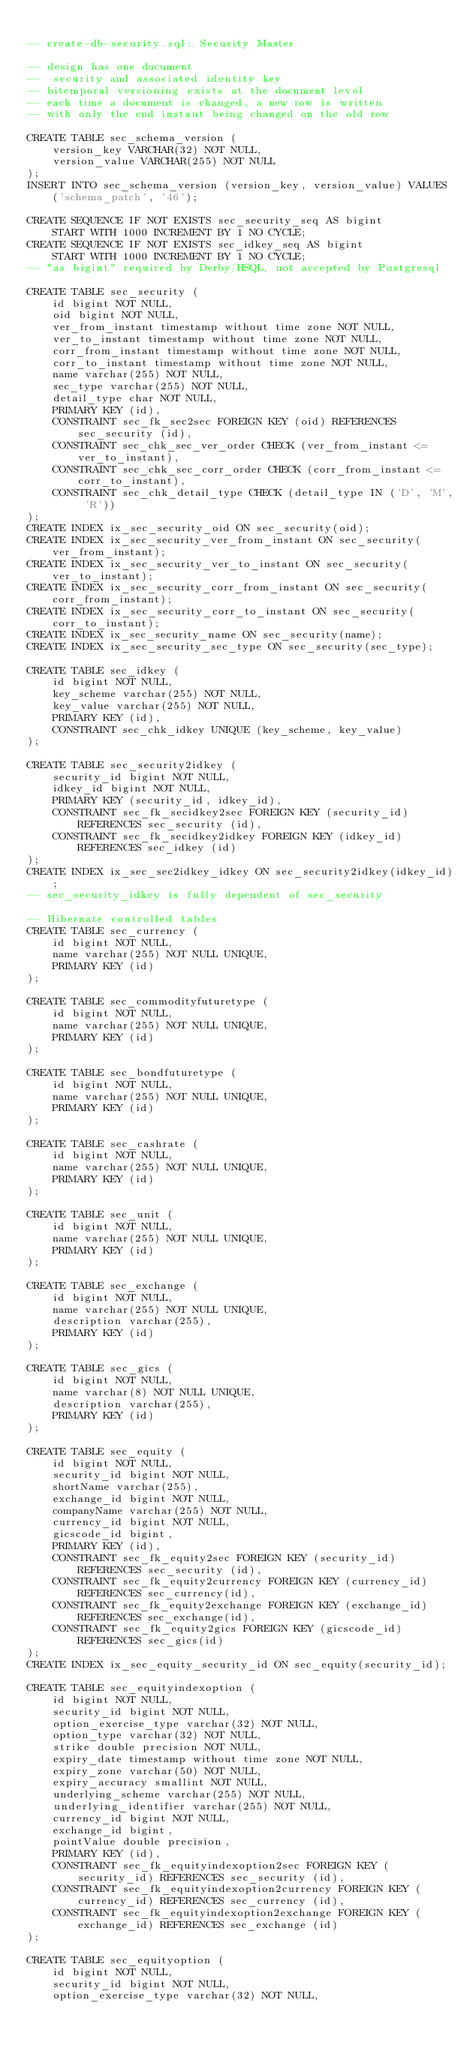<code> <loc_0><loc_0><loc_500><loc_500><_SQL_>
-- create-db-security.sql: Security Master

-- design has one document
--  security and associated identity key
-- bitemporal versioning exists at the document level
-- each time a document is changed, a new row is written
-- with only the end instant being changed on the old row

CREATE TABLE sec_schema_version (
    version_key VARCHAR(32) NOT NULL,
    version_value VARCHAR(255) NOT NULL
);
INSERT INTO sec_schema_version (version_key, version_value) VALUES ('schema_patch', '46');

CREATE SEQUENCE IF NOT EXISTS sec_security_seq AS bigint
    START WITH 1000 INCREMENT BY 1 NO CYCLE;
CREATE SEQUENCE IF NOT EXISTS sec_idkey_seq AS bigint
    START WITH 1000 INCREMENT BY 1 NO CYCLE;
-- "as bigint" required by Derby/HSQL, not accepted by Postgresql

CREATE TABLE sec_security (
    id bigint NOT NULL,
    oid bigint NOT NULL,
    ver_from_instant timestamp without time zone NOT NULL,
    ver_to_instant timestamp without time zone NOT NULL,
    corr_from_instant timestamp without time zone NOT NULL,
    corr_to_instant timestamp without time zone NOT NULL,
    name varchar(255) NOT NULL,
    sec_type varchar(255) NOT NULL,
    detail_type char NOT NULL,
    PRIMARY KEY (id),
    CONSTRAINT sec_fk_sec2sec FOREIGN KEY (oid) REFERENCES sec_security (id),
    CONSTRAINT sec_chk_sec_ver_order CHECK (ver_from_instant <= ver_to_instant),
    CONSTRAINT sec_chk_sec_corr_order CHECK (corr_from_instant <= corr_to_instant),
    CONSTRAINT sec_chk_detail_type CHECK (detail_type IN ('D', 'M', 'R'))
);
CREATE INDEX ix_sec_security_oid ON sec_security(oid);
CREATE INDEX ix_sec_security_ver_from_instant ON sec_security(ver_from_instant);
CREATE INDEX ix_sec_security_ver_to_instant ON sec_security(ver_to_instant);
CREATE INDEX ix_sec_security_corr_from_instant ON sec_security(corr_from_instant);
CREATE INDEX ix_sec_security_corr_to_instant ON sec_security(corr_to_instant);
CREATE INDEX ix_sec_security_name ON sec_security(name);
CREATE INDEX ix_sec_security_sec_type ON sec_security(sec_type);

CREATE TABLE sec_idkey (
    id bigint NOT NULL,
    key_scheme varchar(255) NOT NULL,
    key_value varchar(255) NOT NULL,
    PRIMARY KEY (id),
    CONSTRAINT sec_chk_idkey UNIQUE (key_scheme, key_value)
);

CREATE TABLE sec_security2idkey (
    security_id bigint NOT NULL,
    idkey_id bigint NOT NULL,
    PRIMARY KEY (security_id, idkey_id),
    CONSTRAINT sec_fk_secidkey2sec FOREIGN KEY (security_id) REFERENCES sec_security (id),
    CONSTRAINT sec_fk_secidkey2idkey FOREIGN KEY (idkey_id) REFERENCES sec_idkey (id)
);
CREATE INDEX ix_sec_sec2idkey_idkey ON sec_security2idkey(idkey_id);
-- sec_security_idkey is fully dependent of sec_security

-- Hibernate controlled tables
CREATE TABLE sec_currency (
    id bigint NOT NULL,
    name varchar(255) NOT NULL UNIQUE,
    PRIMARY KEY (id)
);

CREATE TABLE sec_commodityfuturetype (
    id bigint NOT NULL,
    name varchar(255) NOT NULL UNIQUE,
    PRIMARY KEY (id)
);

CREATE TABLE sec_bondfuturetype (
    id bigint NOT NULL,
    name varchar(255) NOT NULL UNIQUE,
    PRIMARY KEY (id)
);

CREATE TABLE sec_cashrate (
    id bigint NOT NULL,
    name varchar(255) NOT NULL UNIQUE,
    PRIMARY KEY (id)
);

CREATE TABLE sec_unit (
    id bigint NOT NULL,
    name varchar(255) NOT NULL UNIQUE,
    PRIMARY KEY (id)
);

CREATE TABLE sec_exchange (
    id bigint NOT NULL,
    name varchar(255) NOT NULL UNIQUE,
    description varchar(255),
    PRIMARY KEY (id)
);

CREATE TABLE sec_gics (
    id bigint NOT NULL,
    name varchar(8) NOT NULL UNIQUE,
    description varchar(255),
    PRIMARY KEY (id)
);

CREATE TABLE sec_equity (
    id bigint NOT NULL,
    security_id bigint NOT NULL,
    shortName varchar(255),
    exchange_id bigint NOT NULL,
    companyName varchar(255) NOT NULL,
    currency_id bigint NOT NULL,
    gicscode_id bigint,
    PRIMARY KEY (id),
    CONSTRAINT sec_fk_equity2sec FOREIGN KEY (security_id) REFERENCES sec_security (id),
    CONSTRAINT sec_fk_equity2currency FOREIGN KEY (currency_id) REFERENCES sec_currency(id),
    CONSTRAINT sec_fk_equity2exchange FOREIGN KEY (exchange_id) REFERENCES sec_exchange(id),
    CONSTRAINT sec_fk_equity2gics FOREIGN KEY (gicscode_id) REFERENCES sec_gics(id)
);
CREATE INDEX ix_sec_equity_security_id ON sec_equity(security_id);

CREATE TABLE sec_equityindexoption (
    id bigint NOT NULL,
    security_id bigint NOT NULL,
    option_exercise_type varchar(32) NOT NULL,
    option_type varchar(32) NOT NULL,
    strike double precision NOT NULL,
    expiry_date timestamp without time zone NOT NULL,
    expiry_zone varchar(50) NOT NULL,
    expiry_accuracy smallint NOT NULL,
    underlying_scheme varchar(255) NOT NULL,
    underlying_identifier varchar(255) NOT NULL,
    currency_id bigint NOT NULL,
    exchange_id bigint,
    pointValue double precision,
    PRIMARY KEY (id),
    CONSTRAINT sec_fk_equityindexoption2sec FOREIGN KEY (security_id) REFERENCES sec_security (id),
    CONSTRAINT sec_fk_equityindexoption2currency FOREIGN KEY (currency_id) REFERENCES sec_currency (id),
    CONSTRAINT sec_fk_equityindexoption2exchange FOREIGN KEY (exchange_id) REFERENCES sec_exchange (id)
);

CREATE TABLE sec_equityoption (
    id bigint NOT NULL,
    security_id bigint NOT NULL,
    option_exercise_type varchar(32) NOT NULL,</code> 